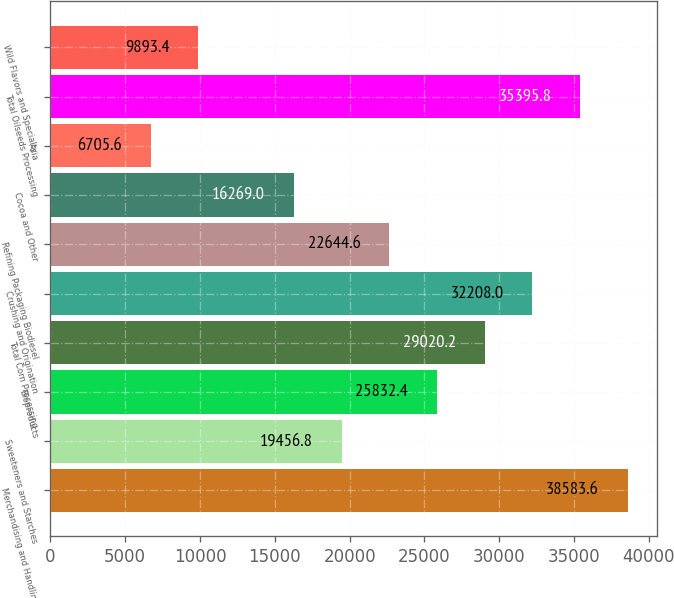Convert chart. <chart><loc_0><loc_0><loc_500><loc_500><bar_chart><fcel>Merchandising and Handling<fcel>Sweeteners and Starches<fcel>Bioproducts<fcel>Total Corn Processing<fcel>Crushing and Origination<fcel>Refining Packaging Biodiesel<fcel>Cocoa and Other<fcel>Asia<fcel>Total Oilseeds Processing<fcel>Wild Flavors and Specialty<nl><fcel>38583.6<fcel>19456.8<fcel>25832.4<fcel>29020.2<fcel>32208<fcel>22644.6<fcel>16269<fcel>6705.6<fcel>35395.8<fcel>9893.4<nl></chart> 